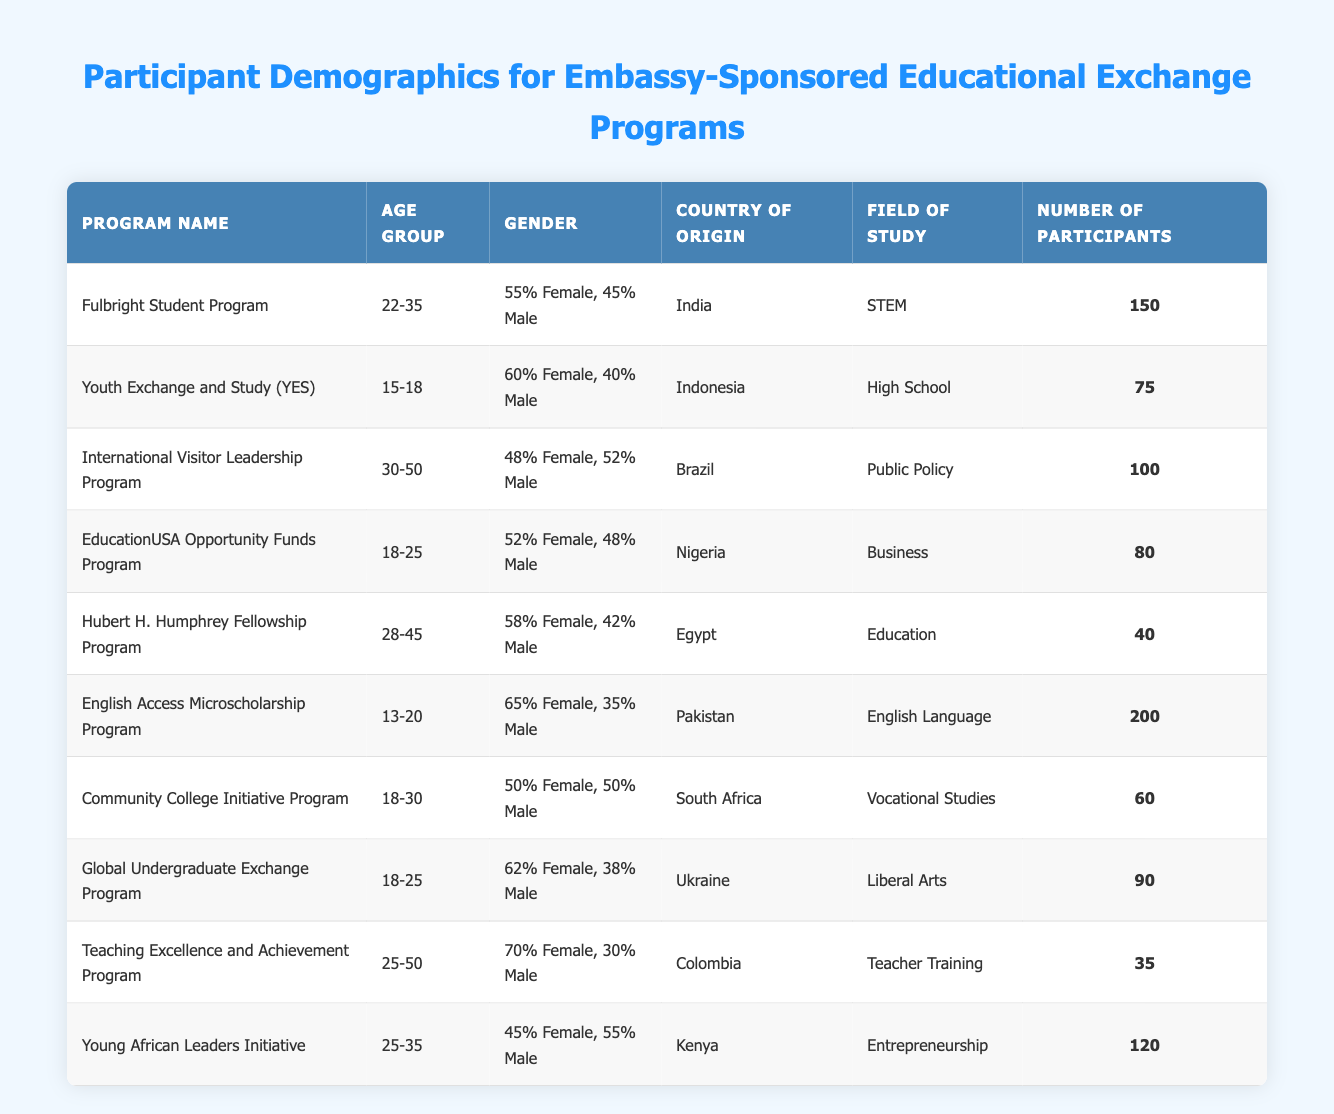What is the total number of participants in the English Access Microscholarship Program? The table shows that the English Access Microscholarship Program has 200 participants. This value is directly listed in the "Number of Participants" column for that program.
Answer: 200 Which program has the highest percentage of female participants? The English Access Microscholarship Program has 65% female participants, which is the highest percentage compared to other programs listed in the table.
Answer: English Access Microscholarship Program Is there a program for the age group 30-50? Yes, the International Visitor Leadership Program is listed for the age group 30-50. This can be confirmed by checking the "Age Group" column for programs under that age category.
Answer: Yes What is the average number of participants across all programs? To calculate the average, we need to sum the number of participants from each program: (150 + 75 + 100 + 80 + 40 + 200 + 60 + 90 + 35 + 120) = 950. Then, we divide it by the number of programs, which is 10: 950/10 = 95. Therefore, the average number of participants is 95.
Answer: 95 Does the Global Undergraduate Exchange Program have more male participants than female participants? No, the Global Undergraduate Exchange Program has 62% female participants and 38% male participants, indicating the number of female participants is greater than that of male participants.
Answer: No Which country of origin has the lowest number of participants in educational exchange programs? The Hubert H. Humphrey Fellowship Program has the lowest number of participants with 40, as noted in the "Number of Participants" column.
Answer: Egypt What is the difference in participants between the Fulbright Student Program and the Youth Exchange and Study (YES)? The Fulbright Student Program has 150 participants, while the Youth Exchange and Study (YES) has 75 participants. The difference is calculated as 150 - 75 = 75.
Answer: 75 Are there any programs focused on the field of study in STEM? Yes, the Fulbright Student Program is focused on the field of STEM. This can be confirmed by checking the "Field of Study" column for relevant programs.
Answer: Yes 